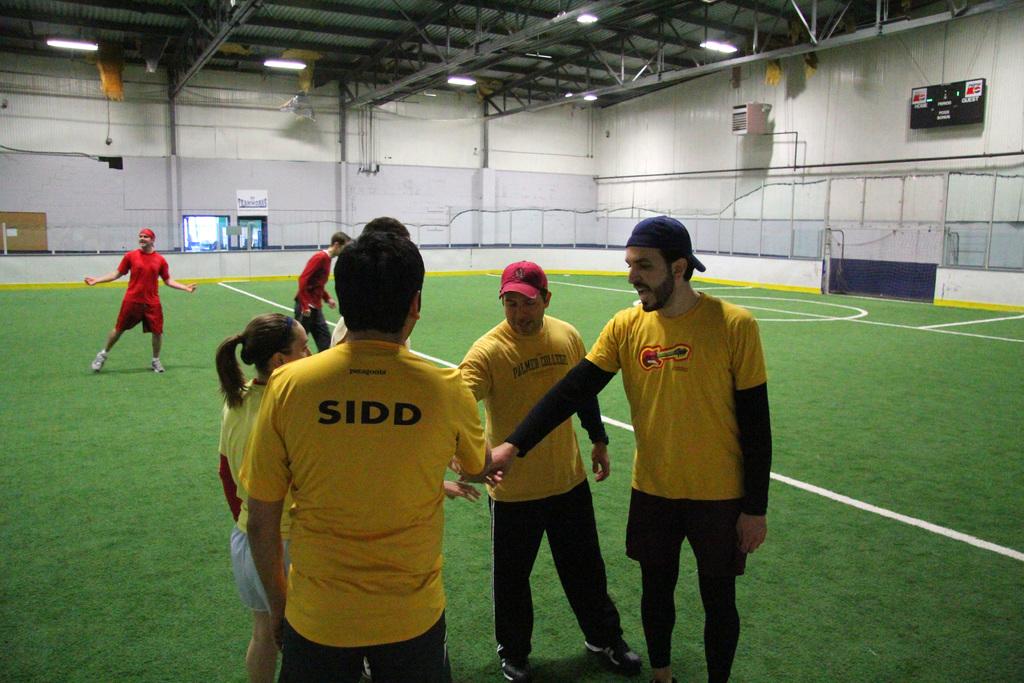What does it say on the back of that guys shirt?
Your answer should be very brief. Sidd. 